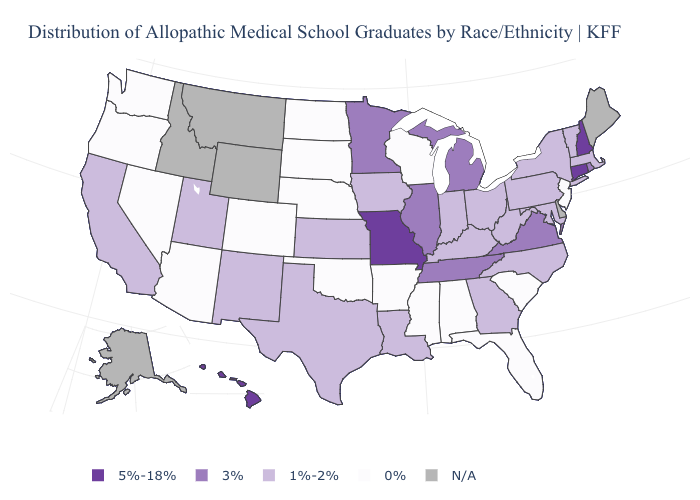Name the states that have a value in the range 0%?
Short answer required. Alabama, Arizona, Arkansas, Colorado, Florida, Mississippi, Nebraska, Nevada, New Jersey, North Dakota, Oklahoma, Oregon, South Carolina, South Dakota, Washington, Wisconsin. How many symbols are there in the legend?
Quick response, please. 5. Which states hav the highest value in the South?
Short answer required. Tennessee, Virginia. Name the states that have a value in the range N/A?
Answer briefly. Alaska, Delaware, Idaho, Maine, Montana, Wyoming. How many symbols are there in the legend?
Concise answer only. 5. What is the highest value in the West ?
Keep it brief. 5%-18%. Does Hawaii have the highest value in the West?
Be succinct. Yes. Does Kansas have the highest value in the MidWest?
Write a very short answer. No. Does Indiana have the lowest value in the MidWest?
Answer briefly. No. What is the value of Florida?
Concise answer only. 0%. What is the value of Colorado?
Be succinct. 0%. What is the value of Nevada?
Quick response, please. 0%. Does Arkansas have the lowest value in the USA?
Keep it brief. Yes. Does Wisconsin have the lowest value in the MidWest?
Write a very short answer. Yes. 